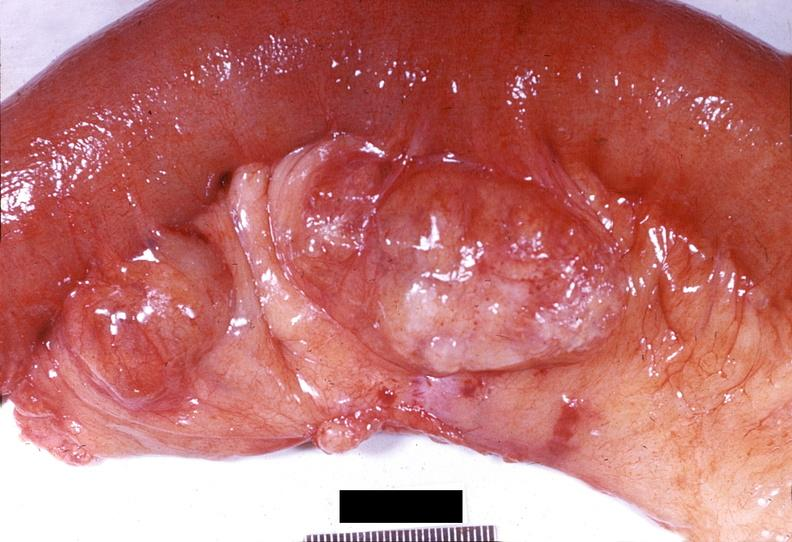what is present?
Answer the question using a single word or phrase. Gastrointestinal 